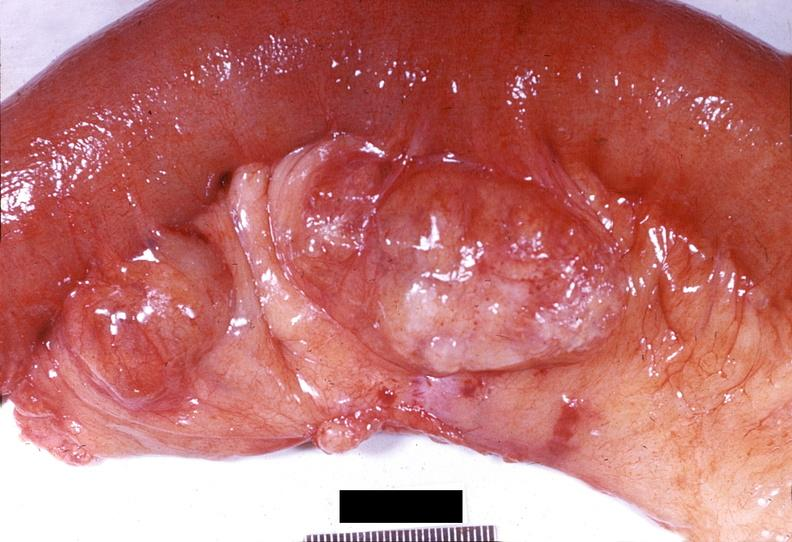what is present?
Answer the question using a single word or phrase. Gastrointestinal 